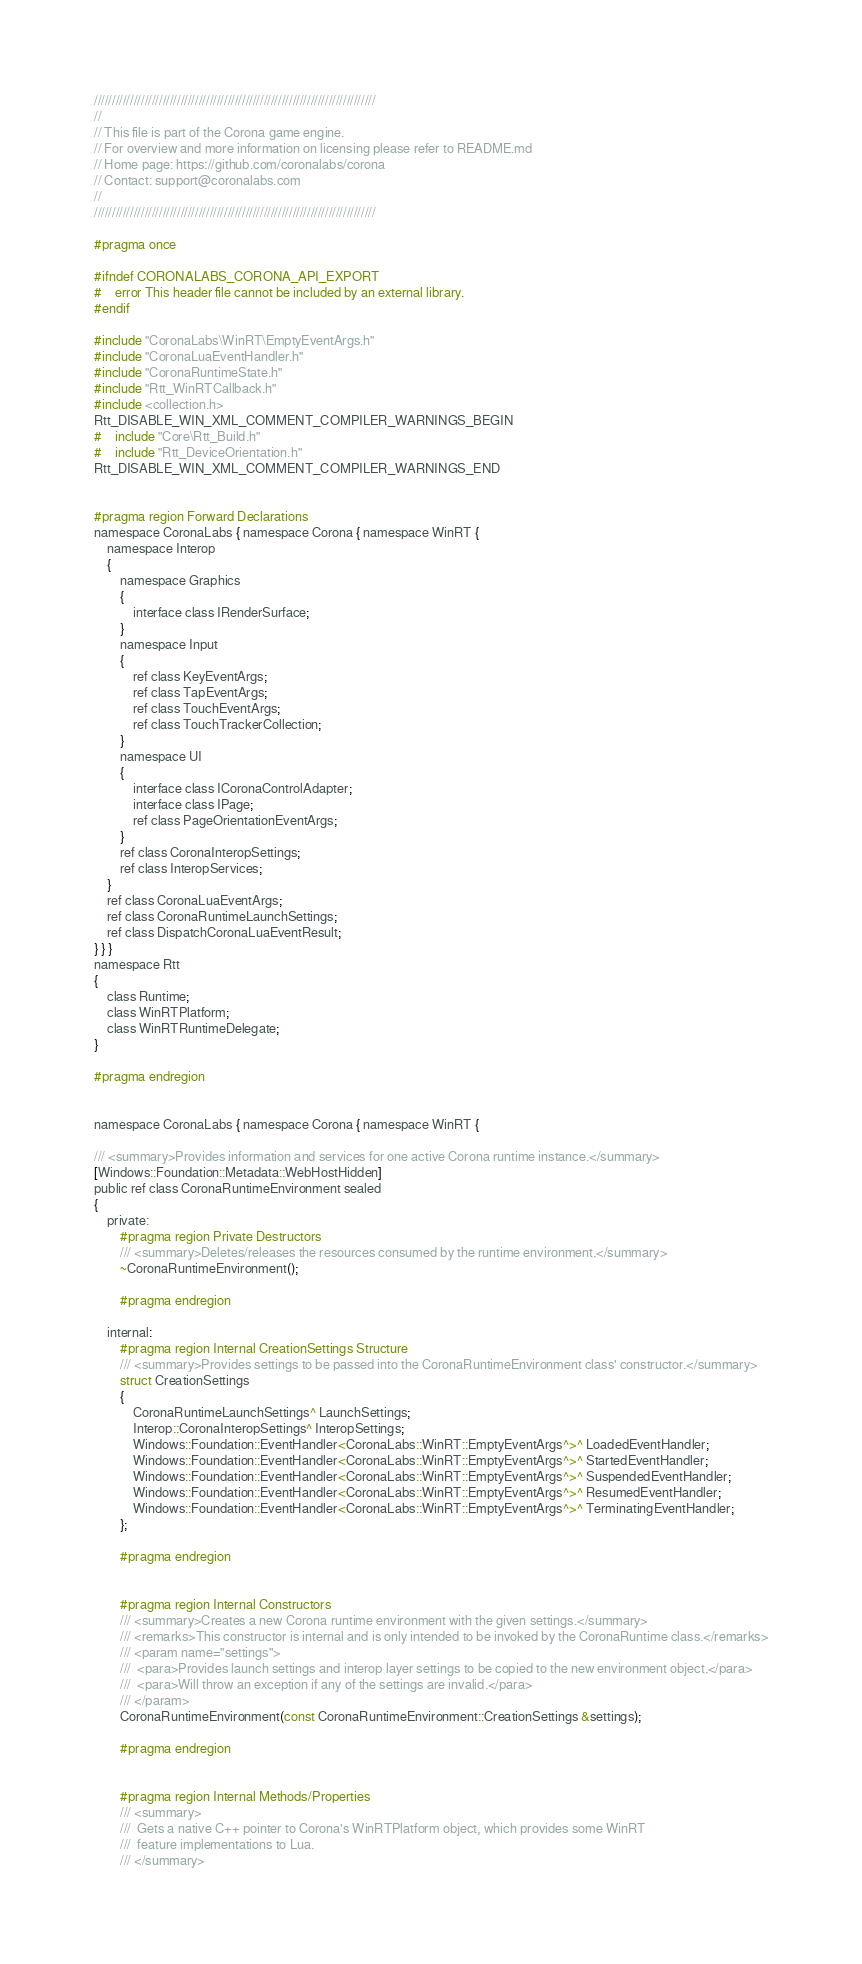<code> <loc_0><loc_0><loc_500><loc_500><_C_>//////////////////////////////////////////////////////////////////////////////
//
// This file is part of the Corona game engine.
// For overview and more information on licensing please refer to README.md 
// Home page: https://github.com/coronalabs/corona
// Contact: support@coronalabs.com
//
//////////////////////////////////////////////////////////////////////////////

#pragma once

#ifndef CORONALABS_CORONA_API_EXPORT
#	error This header file cannot be included by an external library.
#endif

#include "CoronaLabs\WinRT\EmptyEventArgs.h"
#include "CoronaLuaEventHandler.h"
#include "CoronaRuntimeState.h"
#include "Rtt_WinRTCallback.h"
#include <collection.h>
Rtt_DISABLE_WIN_XML_COMMENT_COMPILER_WARNINGS_BEGIN
#	include "Core\Rtt_Build.h"
#	include "Rtt_DeviceOrientation.h"
Rtt_DISABLE_WIN_XML_COMMENT_COMPILER_WARNINGS_END


#pragma region Forward Declarations
namespace CoronaLabs { namespace Corona { namespace WinRT {
	namespace Interop
	{
		namespace Graphics
		{
			interface class IRenderSurface;
		}
		namespace Input
		{
			ref class KeyEventArgs;
			ref class TapEventArgs;
			ref class TouchEventArgs;
			ref class TouchTrackerCollection;
		}
		namespace UI
		{
			interface class ICoronaControlAdapter;
			interface class IPage;
			ref class PageOrientationEventArgs;
		}
		ref class CoronaInteropSettings;
		ref class InteropServices;
	}
	ref class CoronaLuaEventArgs;
	ref class CoronaRuntimeLaunchSettings;
	ref class DispatchCoronaLuaEventResult;
} } }
namespace Rtt
{
	class Runtime;
	class WinRTPlatform;
	class WinRTRuntimeDelegate;
}

#pragma endregion


namespace CoronaLabs { namespace Corona { namespace WinRT {

/// <summary>Provides information and services for one active Corona runtime instance.</summary>
[Windows::Foundation::Metadata::WebHostHidden]
public ref class CoronaRuntimeEnvironment sealed
{
	private:
		#pragma region Private Destructors
		/// <summary>Deletes/releases the resources consumed by the runtime environment.</summary>
		~CoronaRuntimeEnvironment();

		#pragma endregion

	internal:
		#pragma region Internal CreationSettings Structure
		/// <summary>Provides settings to be passed into the CoronaRuntimeEnvironment class' constructor.</summary>
		struct CreationSettings
		{
			CoronaRuntimeLaunchSettings^ LaunchSettings;
			Interop::CoronaInteropSettings^ InteropSettings;
			Windows::Foundation::EventHandler<CoronaLabs::WinRT::EmptyEventArgs^>^ LoadedEventHandler;
			Windows::Foundation::EventHandler<CoronaLabs::WinRT::EmptyEventArgs^>^ StartedEventHandler;
			Windows::Foundation::EventHandler<CoronaLabs::WinRT::EmptyEventArgs^>^ SuspendedEventHandler;
			Windows::Foundation::EventHandler<CoronaLabs::WinRT::EmptyEventArgs^>^ ResumedEventHandler;
			Windows::Foundation::EventHandler<CoronaLabs::WinRT::EmptyEventArgs^>^ TerminatingEventHandler;
		};

		#pragma endregion


		#pragma region Internal Constructors
		/// <summary>Creates a new Corona runtime environment with the given settings.</summary>
		/// <remarks>This constructor is internal and is only intended to be invoked by the CoronaRuntime class.</remarks>
		/// <param name="settings">
		///  <para>Provides launch settings and interop layer settings to be copied to the new environment object.</para>
		///  <para>Will throw an exception if any of the settings are invalid.</para>
		/// </param>
		CoronaRuntimeEnvironment(const CoronaRuntimeEnvironment::CreationSettings &settings);

		#pragma endregion


		#pragma region Internal Methods/Properties
		/// <summary>
		///  Gets a native C++ pointer to Corona's WinRTPlatform object, which provides some WinRT
		///  feature implementations to Lua.
		/// </summary></code> 